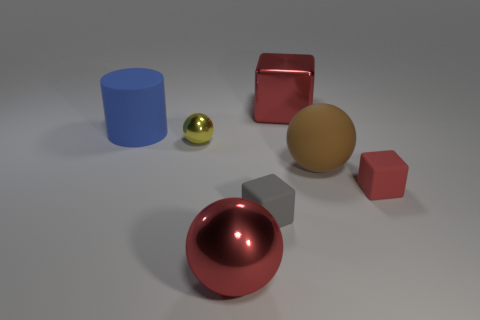There is a red metallic thing that is the same shape as the gray rubber object; what is its size?
Keep it short and to the point. Large. What number of brown objects are blocks or tiny matte things?
Keep it short and to the point. 0. There is a big object that is behind the large blue thing; how many small red objects are in front of it?
Your answer should be very brief. 1. What number of other things are there of the same shape as the blue matte object?
Your answer should be very brief. 0. What is the material of the small cube that is the same color as the large metallic ball?
Offer a terse response. Rubber. What number of tiny blocks are the same color as the large matte sphere?
Provide a short and direct response. 0. What is the color of the tiny thing that is the same material as the tiny red block?
Make the answer very short. Gray. Is there a cyan rubber object that has the same size as the yellow object?
Offer a terse response. No. Are there more small red objects that are in front of the rubber sphere than red blocks to the left of the red sphere?
Keep it short and to the point. Yes. Is the red thing that is behind the yellow metallic sphere made of the same material as the cylinder that is behind the red sphere?
Offer a very short reply. No. 